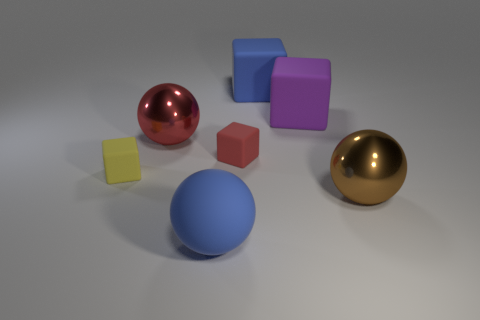Is the number of balls that are in front of the yellow block less than the number of large objects?
Give a very brief answer. Yes. Does the blue matte thing behind the yellow cube have the same size as the yellow block?
Offer a very short reply. No. How many big things are both on the right side of the purple rubber block and in front of the brown object?
Provide a succinct answer. 0. There is a shiny ball that is right of the large blue matte object behind the blue sphere; how big is it?
Offer a terse response. Large. Are there fewer metallic objects that are in front of the large red metallic thing than blocks that are in front of the big blue cube?
Your response must be concise. Yes. Is the color of the metal object behind the tiny yellow matte block the same as the small rubber cube right of the red shiny ball?
Your answer should be compact. Yes. What is the object that is on the left side of the large blue ball and on the right side of the tiny yellow matte cube made of?
Your response must be concise. Metal. Is there a red shiny cylinder?
Provide a short and direct response. No. There is a object that is the same material as the large red sphere; what is its shape?
Ensure brevity in your answer.  Sphere. There is a large purple rubber thing; does it have the same shape as the blue rubber thing behind the large brown metallic ball?
Offer a very short reply. Yes. 